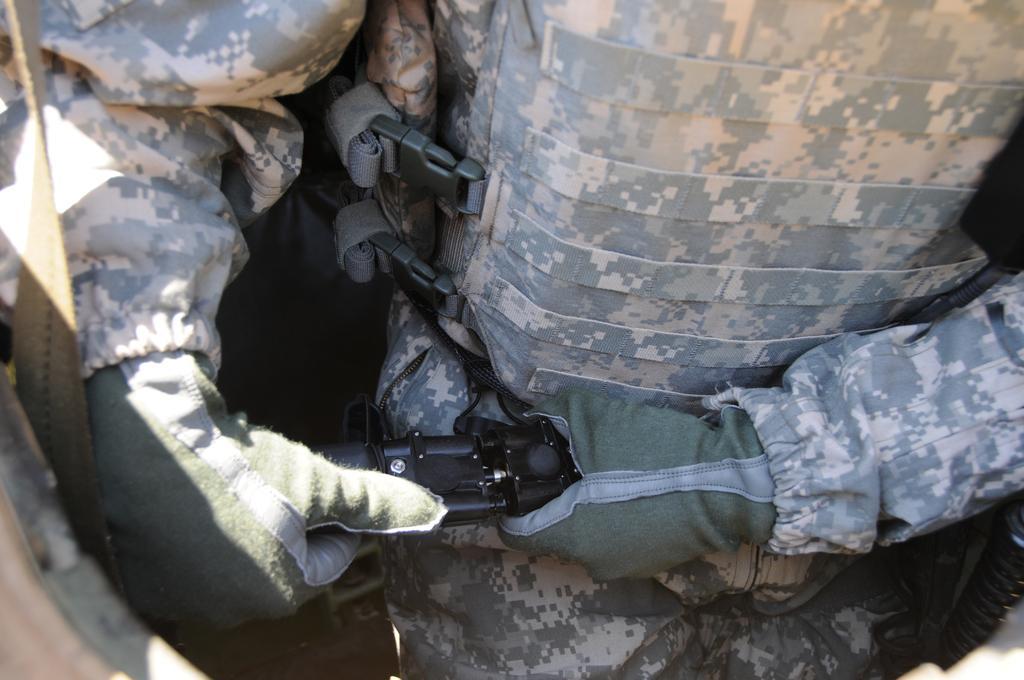Could you give a brief overview of what you see in this image? In this image we can see a person wearing a jacket and gloves. He is holding some object in his hand. 